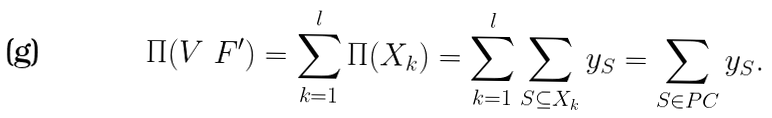Convert formula to latex. <formula><loc_0><loc_0><loc_500><loc_500>\Pi ( V \ F ^ { \prime } ) = \sum _ { k = 1 } ^ { l } \Pi ( X _ { k } ) = \sum _ { k = 1 } ^ { l } \sum _ { S \subseteq X _ { k } } y _ { S } = \sum _ { S \in P C } y _ { S } .</formula> 